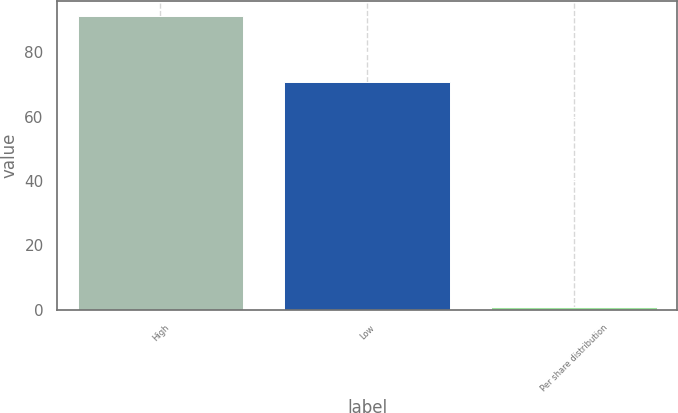Convert chart. <chart><loc_0><loc_0><loc_500><loc_500><bar_chart><fcel>High<fcel>Low<fcel>Per share distribution<nl><fcel>91.25<fcel>70.69<fcel>0.8<nl></chart> 